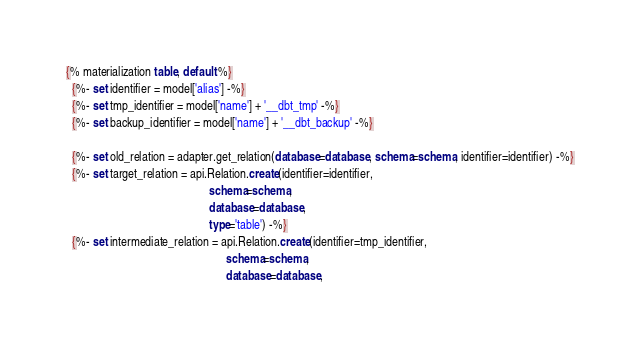Convert code to text. <code><loc_0><loc_0><loc_500><loc_500><_SQL_>{% materialization table, default %}
  {%- set identifier = model['alias'] -%}
  {%- set tmp_identifier = model['name'] + '__dbt_tmp' -%}
  {%- set backup_identifier = model['name'] + '__dbt_backup' -%}

  {%- set old_relation = adapter.get_relation(database=database, schema=schema, identifier=identifier) -%}
  {%- set target_relation = api.Relation.create(identifier=identifier,
                                                schema=schema,
                                                database=database,
                                                type='table') -%}
  {%- set intermediate_relation = api.Relation.create(identifier=tmp_identifier,
                                                      schema=schema,
                                                      database=database,</code> 